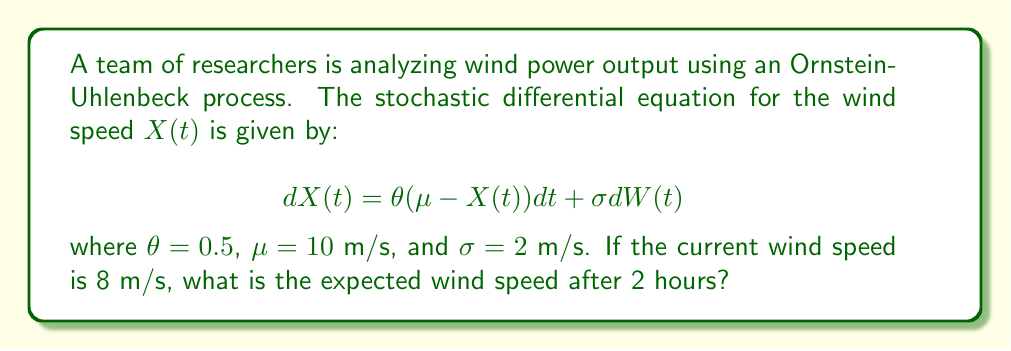Can you solve this math problem? To solve this problem, we'll follow these steps:

1) The Ornstein-Uhlenbeck process has a mean-reverting property. The expected value of $X(t)$ given $X(0) = x_0$ is:

   $$E[X(t)|X(0) = x_0] = \mu + (x_0 - \mu)e^{-\theta t}$$

2) In our case:
   - $\mu = 10$ m/s (long-term mean)
   - $x_0 = 8$ m/s (current wind speed)
   - $\theta = 0.5$ (mean reversion rate)
   - $t = 2$ hours

3) Let's substitute these values into the equation:

   $$E[X(2)|X(0) = 8] = 10 + (8 - 10)e^{-0.5 \cdot 2}$$

4) Simplify:
   $$E[X(2)|X(0) = 8] = 10 - 2e^{-1}$$

5) Calculate:
   $$E[X(2)|X(0) = 8] = 10 - 2 \cdot 0.3679 = 10 - 0.7358 = 9.2642$$

Therefore, the expected wind speed after 2 hours is approximately 9.26 m/s.
Answer: 9.26 m/s 